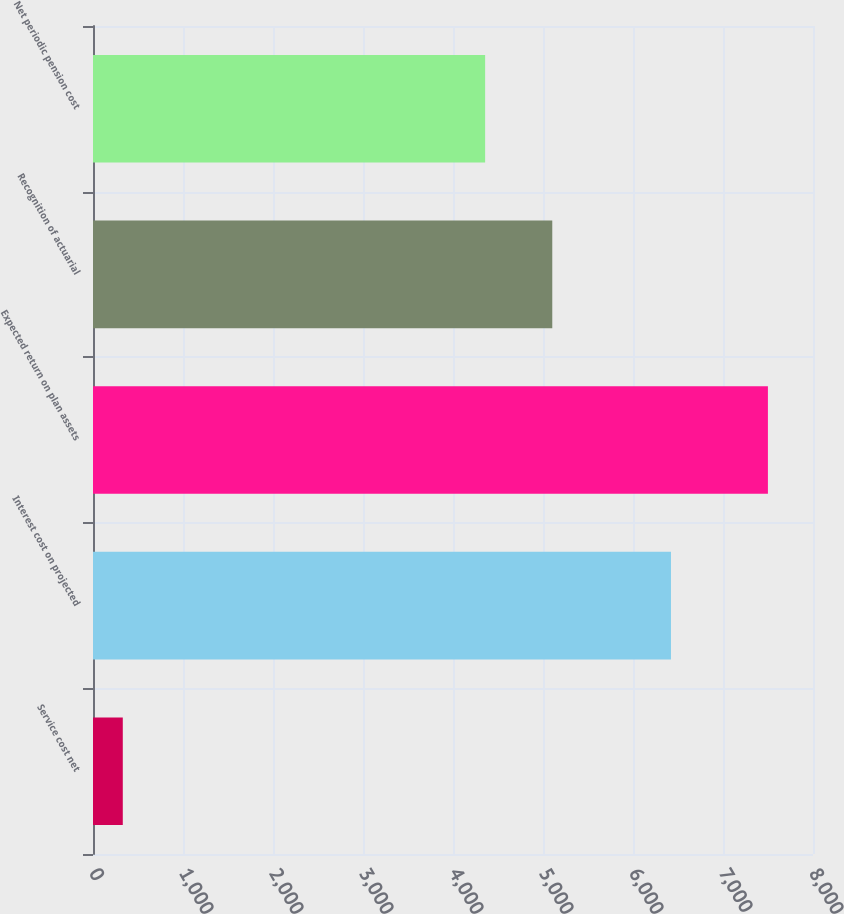Convert chart. <chart><loc_0><loc_0><loc_500><loc_500><bar_chart><fcel>Service cost net<fcel>Interest cost on projected<fcel>Expected return on plan assets<fcel>Recognition of actuarial<fcel>Net periodic pension cost<nl><fcel>331<fcel>6422<fcel>7499<fcel>5103<fcel>4357<nl></chart> 